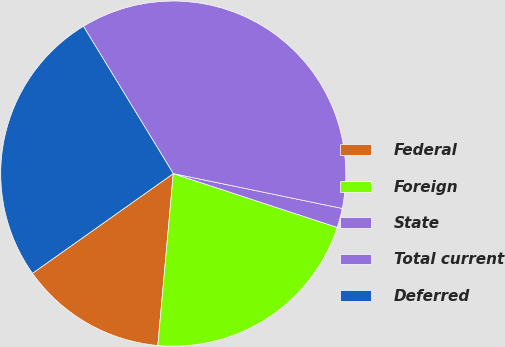<chart> <loc_0><loc_0><loc_500><loc_500><pie_chart><fcel>Federal<fcel>Foreign<fcel>State<fcel>Total current<fcel>Deferred<nl><fcel>13.77%<fcel>21.38%<fcel>1.81%<fcel>36.96%<fcel>26.09%<nl></chart> 